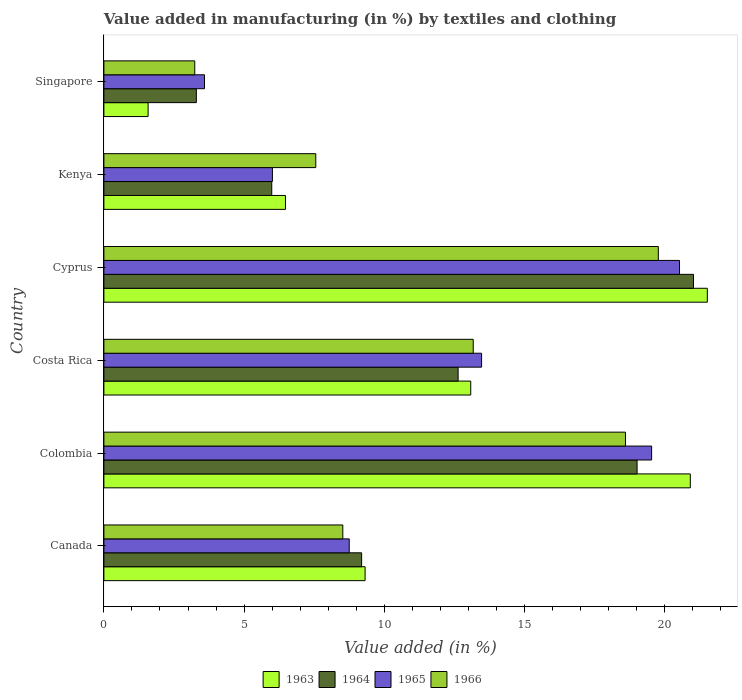Are the number of bars on each tick of the Y-axis equal?
Provide a short and direct response. Yes. How many bars are there on the 1st tick from the top?
Give a very brief answer. 4. How many bars are there on the 4th tick from the bottom?
Your answer should be compact. 4. What is the label of the 3rd group of bars from the top?
Your answer should be very brief. Cyprus. What is the percentage of value added in manufacturing by textiles and clothing in 1966 in Colombia?
Your response must be concise. 18.6. Across all countries, what is the maximum percentage of value added in manufacturing by textiles and clothing in 1966?
Your answer should be compact. 19.78. Across all countries, what is the minimum percentage of value added in manufacturing by textiles and clothing in 1966?
Give a very brief answer. 3.24. In which country was the percentage of value added in manufacturing by textiles and clothing in 1966 maximum?
Give a very brief answer. Cyprus. In which country was the percentage of value added in manufacturing by textiles and clothing in 1966 minimum?
Ensure brevity in your answer.  Singapore. What is the total percentage of value added in manufacturing by textiles and clothing in 1963 in the graph?
Offer a terse response. 72.9. What is the difference between the percentage of value added in manufacturing by textiles and clothing in 1964 in Costa Rica and that in Cyprus?
Keep it short and to the point. -8.4. What is the difference between the percentage of value added in manufacturing by textiles and clothing in 1963 in Costa Rica and the percentage of value added in manufacturing by textiles and clothing in 1964 in Singapore?
Your answer should be compact. 9.79. What is the average percentage of value added in manufacturing by textiles and clothing in 1966 per country?
Make the answer very short. 11.81. What is the difference between the percentage of value added in manufacturing by textiles and clothing in 1966 and percentage of value added in manufacturing by textiles and clothing in 1965 in Cyprus?
Your answer should be very brief. -0.76. In how many countries, is the percentage of value added in manufacturing by textiles and clothing in 1965 greater than 1 %?
Keep it short and to the point. 6. What is the ratio of the percentage of value added in manufacturing by textiles and clothing in 1966 in Canada to that in Singapore?
Offer a very short reply. 2.63. Is the percentage of value added in manufacturing by textiles and clothing in 1964 in Kenya less than that in Singapore?
Offer a very short reply. No. Is the difference between the percentage of value added in manufacturing by textiles and clothing in 1966 in Costa Rica and Cyprus greater than the difference between the percentage of value added in manufacturing by textiles and clothing in 1965 in Costa Rica and Cyprus?
Give a very brief answer. Yes. What is the difference between the highest and the second highest percentage of value added in manufacturing by textiles and clothing in 1966?
Give a very brief answer. 1.17. What is the difference between the highest and the lowest percentage of value added in manufacturing by textiles and clothing in 1963?
Your answer should be compact. 19.95. In how many countries, is the percentage of value added in manufacturing by textiles and clothing in 1964 greater than the average percentage of value added in manufacturing by textiles and clothing in 1964 taken over all countries?
Offer a terse response. 3. What does the 3rd bar from the top in Costa Rica represents?
Offer a terse response. 1964. What does the 3rd bar from the bottom in Kenya represents?
Your response must be concise. 1965. How many bars are there?
Your answer should be very brief. 24. How many countries are there in the graph?
Give a very brief answer. 6. What is the difference between two consecutive major ticks on the X-axis?
Your answer should be very brief. 5. Does the graph contain grids?
Provide a succinct answer. No. Where does the legend appear in the graph?
Your response must be concise. Bottom center. How many legend labels are there?
Give a very brief answer. 4. How are the legend labels stacked?
Your answer should be compact. Horizontal. What is the title of the graph?
Keep it short and to the point. Value added in manufacturing (in %) by textiles and clothing. Does "1987" appear as one of the legend labels in the graph?
Your answer should be compact. No. What is the label or title of the X-axis?
Make the answer very short. Value added (in %). What is the Value added (in %) in 1963 in Canada?
Ensure brevity in your answer.  9.32. What is the Value added (in %) of 1964 in Canada?
Give a very brief answer. 9.19. What is the Value added (in %) in 1965 in Canada?
Offer a very short reply. 8.75. What is the Value added (in %) in 1966 in Canada?
Offer a terse response. 8.52. What is the Value added (in %) of 1963 in Colombia?
Provide a succinct answer. 20.92. What is the Value added (in %) of 1964 in Colombia?
Keep it short and to the point. 19.02. What is the Value added (in %) of 1965 in Colombia?
Keep it short and to the point. 19.54. What is the Value added (in %) in 1966 in Colombia?
Make the answer very short. 18.6. What is the Value added (in %) in 1963 in Costa Rica?
Offer a very short reply. 13.08. What is the Value added (in %) in 1964 in Costa Rica?
Provide a short and direct response. 12.63. What is the Value added (in %) in 1965 in Costa Rica?
Provide a succinct answer. 13.47. What is the Value added (in %) in 1966 in Costa Rica?
Ensure brevity in your answer.  13.17. What is the Value added (in %) of 1963 in Cyprus?
Provide a short and direct response. 21.52. What is the Value added (in %) in 1964 in Cyprus?
Keep it short and to the point. 21.03. What is the Value added (in %) of 1965 in Cyprus?
Provide a succinct answer. 20.53. What is the Value added (in %) in 1966 in Cyprus?
Your answer should be compact. 19.78. What is the Value added (in %) in 1963 in Kenya?
Offer a very short reply. 6.48. What is the Value added (in %) of 1964 in Kenya?
Your answer should be very brief. 5.99. What is the Value added (in %) of 1965 in Kenya?
Ensure brevity in your answer.  6.01. What is the Value added (in %) of 1966 in Kenya?
Provide a succinct answer. 7.56. What is the Value added (in %) in 1963 in Singapore?
Your response must be concise. 1.58. What is the Value added (in %) of 1964 in Singapore?
Provide a succinct answer. 3.3. What is the Value added (in %) of 1965 in Singapore?
Provide a short and direct response. 3.59. What is the Value added (in %) of 1966 in Singapore?
Your answer should be compact. 3.24. Across all countries, what is the maximum Value added (in %) of 1963?
Provide a short and direct response. 21.52. Across all countries, what is the maximum Value added (in %) of 1964?
Your response must be concise. 21.03. Across all countries, what is the maximum Value added (in %) in 1965?
Ensure brevity in your answer.  20.53. Across all countries, what is the maximum Value added (in %) of 1966?
Ensure brevity in your answer.  19.78. Across all countries, what is the minimum Value added (in %) of 1963?
Your answer should be compact. 1.58. Across all countries, what is the minimum Value added (in %) of 1964?
Give a very brief answer. 3.3. Across all countries, what is the minimum Value added (in %) in 1965?
Offer a terse response. 3.59. Across all countries, what is the minimum Value added (in %) of 1966?
Offer a very short reply. 3.24. What is the total Value added (in %) in 1963 in the graph?
Your answer should be compact. 72.9. What is the total Value added (in %) in 1964 in the graph?
Your response must be concise. 71.16. What is the total Value added (in %) of 1965 in the graph?
Make the answer very short. 71.89. What is the total Value added (in %) of 1966 in the graph?
Offer a very short reply. 70.87. What is the difference between the Value added (in %) of 1963 in Canada and that in Colombia?
Provide a short and direct response. -11.6. What is the difference between the Value added (in %) in 1964 in Canada and that in Colombia?
Give a very brief answer. -9.82. What is the difference between the Value added (in %) in 1965 in Canada and that in Colombia?
Provide a short and direct response. -10.79. What is the difference between the Value added (in %) in 1966 in Canada and that in Colombia?
Your answer should be compact. -10.08. What is the difference between the Value added (in %) in 1963 in Canada and that in Costa Rica?
Provide a short and direct response. -3.77. What is the difference between the Value added (in %) in 1964 in Canada and that in Costa Rica?
Provide a succinct answer. -3.44. What is the difference between the Value added (in %) in 1965 in Canada and that in Costa Rica?
Give a very brief answer. -4.72. What is the difference between the Value added (in %) of 1966 in Canada and that in Costa Rica?
Your response must be concise. -4.65. What is the difference between the Value added (in %) of 1963 in Canada and that in Cyprus?
Ensure brevity in your answer.  -12.21. What is the difference between the Value added (in %) of 1964 in Canada and that in Cyprus?
Offer a very short reply. -11.84. What is the difference between the Value added (in %) in 1965 in Canada and that in Cyprus?
Your answer should be compact. -11.78. What is the difference between the Value added (in %) in 1966 in Canada and that in Cyprus?
Your response must be concise. -11.25. What is the difference between the Value added (in %) of 1963 in Canada and that in Kenya?
Your answer should be very brief. 2.84. What is the difference between the Value added (in %) in 1964 in Canada and that in Kenya?
Offer a very short reply. 3.21. What is the difference between the Value added (in %) of 1965 in Canada and that in Kenya?
Give a very brief answer. 2.74. What is the difference between the Value added (in %) in 1966 in Canada and that in Kenya?
Offer a very short reply. 0.96. What is the difference between the Value added (in %) in 1963 in Canada and that in Singapore?
Provide a succinct answer. 7.74. What is the difference between the Value added (in %) in 1964 in Canada and that in Singapore?
Provide a short and direct response. 5.9. What is the difference between the Value added (in %) of 1965 in Canada and that in Singapore?
Provide a succinct answer. 5.16. What is the difference between the Value added (in %) in 1966 in Canada and that in Singapore?
Your response must be concise. 5.28. What is the difference between the Value added (in %) in 1963 in Colombia and that in Costa Rica?
Ensure brevity in your answer.  7.83. What is the difference between the Value added (in %) in 1964 in Colombia and that in Costa Rica?
Provide a succinct answer. 6.38. What is the difference between the Value added (in %) of 1965 in Colombia and that in Costa Rica?
Provide a succinct answer. 6.06. What is the difference between the Value added (in %) of 1966 in Colombia and that in Costa Rica?
Make the answer very short. 5.43. What is the difference between the Value added (in %) in 1963 in Colombia and that in Cyprus?
Provide a succinct answer. -0.61. What is the difference between the Value added (in %) of 1964 in Colombia and that in Cyprus?
Make the answer very short. -2.01. What is the difference between the Value added (in %) of 1965 in Colombia and that in Cyprus?
Ensure brevity in your answer.  -0.99. What is the difference between the Value added (in %) in 1966 in Colombia and that in Cyprus?
Keep it short and to the point. -1.17. What is the difference between the Value added (in %) of 1963 in Colombia and that in Kenya?
Keep it short and to the point. 14.44. What is the difference between the Value added (in %) in 1964 in Colombia and that in Kenya?
Give a very brief answer. 13.03. What is the difference between the Value added (in %) of 1965 in Colombia and that in Kenya?
Your answer should be very brief. 13.53. What is the difference between the Value added (in %) in 1966 in Colombia and that in Kenya?
Your response must be concise. 11.05. What is the difference between the Value added (in %) of 1963 in Colombia and that in Singapore?
Offer a very short reply. 19.34. What is the difference between the Value added (in %) of 1964 in Colombia and that in Singapore?
Provide a succinct answer. 15.72. What is the difference between the Value added (in %) in 1965 in Colombia and that in Singapore?
Provide a short and direct response. 15.95. What is the difference between the Value added (in %) of 1966 in Colombia and that in Singapore?
Offer a very short reply. 15.36. What is the difference between the Value added (in %) in 1963 in Costa Rica and that in Cyprus?
Make the answer very short. -8.44. What is the difference between the Value added (in %) of 1964 in Costa Rica and that in Cyprus?
Make the answer very short. -8.4. What is the difference between the Value added (in %) of 1965 in Costa Rica and that in Cyprus?
Keep it short and to the point. -7.06. What is the difference between the Value added (in %) of 1966 in Costa Rica and that in Cyprus?
Make the answer very short. -6.6. What is the difference between the Value added (in %) in 1963 in Costa Rica and that in Kenya?
Make the answer very short. 6.61. What is the difference between the Value added (in %) of 1964 in Costa Rica and that in Kenya?
Provide a succinct answer. 6.65. What is the difference between the Value added (in %) of 1965 in Costa Rica and that in Kenya?
Your answer should be compact. 7.46. What is the difference between the Value added (in %) in 1966 in Costa Rica and that in Kenya?
Keep it short and to the point. 5.62. What is the difference between the Value added (in %) in 1963 in Costa Rica and that in Singapore?
Offer a very short reply. 11.51. What is the difference between the Value added (in %) in 1964 in Costa Rica and that in Singapore?
Give a very brief answer. 9.34. What is the difference between the Value added (in %) in 1965 in Costa Rica and that in Singapore?
Your answer should be compact. 9.88. What is the difference between the Value added (in %) in 1966 in Costa Rica and that in Singapore?
Offer a terse response. 9.93. What is the difference between the Value added (in %) in 1963 in Cyprus and that in Kenya?
Offer a terse response. 15.05. What is the difference between the Value added (in %) in 1964 in Cyprus and that in Kenya?
Your answer should be compact. 15.04. What is the difference between the Value added (in %) of 1965 in Cyprus and that in Kenya?
Your answer should be compact. 14.52. What is the difference between the Value added (in %) in 1966 in Cyprus and that in Kenya?
Offer a very short reply. 12.22. What is the difference between the Value added (in %) of 1963 in Cyprus and that in Singapore?
Keep it short and to the point. 19.95. What is the difference between the Value added (in %) of 1964 in Cyprus and that in Singapore?
Your answer should be very brief. 17.73. What is the difference between the Value added (in %) of 1965 in Cyprus and that in Singapore?
Keep it short and to the point. 16.94. What is the difference between the Value added (in %) in 1966 in Cyprus and that in Singapore?
Your response must be concise. 16.53. What is the difference between the Value added (in %) of 1963 in Kenya and that in Singapore?
Keep it short and to the point. 4.9. What is the difference between the Value added (in %) in 1964 in Kenya and that in Singapore?
Your answer should be compact. 2.69. What is the difference between the Value added (in %) in 1965 in Kenya and that in Singapore?
Offer a terse response. 2.42. What is the difference between the Value added (in %) in 1966 in Kenya and that in Singapore?
Your answer should be very brief. 4.32. What is the difference between the Value added (in %) in 1963 in Canada and the Value added (in %) in 1964 in Colombia?
Provide a succinct answer. -9.7. What is the difference between the Value added (in %) of 1963 in Canada and the Value added (in %) of 1965 in Colombia?
Keep it short and to the point. -10.22. What is the difference between the Value added (in %) of 1963 in Canada and the Value added (in %) of 1966 in Colombia?
Your answer should be very brief. -9.29. What is the difference between the Value added (in %) of 1964 in Canada and the Value added (in %) of 1965 in Colombia?
Your answer should be compact. -10.34. What is the difference between the Value added (in %) of 1964 in Canada and the Value added (in %) of 1966 in Colombia?
Your answer should be compact. -9.41. What is the difference between the Value added (in %) in 1965 in Canada and the Value added (in %) in 1966 in Colombia?
Your answer should be very brief. -9.85. What is the difference between the Value added (in %) of 1963 in Canada and the Value added (in %) of 1964 in Costa Rica?
Ensure brevity in your answer.  -3.32. What is the difference between the Value added (in %) of 1963 in Canada and the Value added (in %) of 1965 in Costa Rica?
Your response must be concise. -4.16. What is the difference between the Value added (in %) in 1963 in Canada and the Value added (in %) in 1966 in Costa Rica?
Provide a short and direct response. -3.86. What is the difference between the Value added (in %) of 1964 in Canada and the Value added (in %) of 1965 in Costa Rica?
Provide a succinct answer. -4.28. What is the difference between the Value added (in %) of 1964 in Canada and the Value added (in %) of 1966 in Costa Rica?
Provide a succinct answer. -3.98. What is the difference between the Value added (in %) of 1965 in Canada and the Value added (in %) of 1966 in Costa Rica?
Make the answer very short. -4.42. What is the difference between the Value added (in %) in 1963 in Canada and the Value added (in %) in 1964 in Cyprus?
Offer a very short reply. -11.71. What is the difference between the Value added (in %) in 1963 in Canada and the Value added (in %) in 1965 in Cyprus?
Your response must be concise. -11.21. What is the difference between the Value added (in %) in 1963 in Canada and the Value added (in %) in 1966 in Cyprus?
Your answer should be compact. -10.46. What is the difference between the Value added (in %) of 1964 in Canada and the Value added (in %) of 1965 in Cyprus?
Provide a short and direct response. -11.34. What is the difference between the Value added (in %) of 1964 in Canada and the Value added (in %) of 1966 in Cyprus?
Make the answer very short. -10.58. What is the difference between the Value added (in %) in 1965 in Canada and the Value added (in %) in 1966 in Cyprus?
Offer a terse response. -11.02. What is the difference between the Value added (in %) in 1963 in Canada and the Value added (in %) in 1964 in Kenya?
Your answer should be compact. 3.33. What is the difference between the Value added (in %) of 1963 in Canada and the Value added (in %) of 1965 in Kenya?
Offer a terse response. 3.31. What is the difference between the Value added (in %) in 1963 in Canada and the Value added (in %) in 1966 in Kenya?
Your answer should be very brief. 1.76. What is the difference between the Value added (in %) of 1964 in Canada and the Value added (in %) of 1965 in Kenya?
Make the answer very short. 3.18. What is the difference between the Value added (in %) of 1964 in Canada and the Value added (in %) of 1966 in Kenya?
Offer a terse response. 1.64. What is the difference between the Value added (in %) in 1965 in Canada and the Value added (in %) in 1966 in Kenya?
Ensure brevity in your answer.  1.19. What is the difference between the Value added (in %) of 1963 in Canada and the Value added (in %) of 1964 in Singapore?
Offer a very short reply. 6.02. What is the difference between the Value added (in %) in 1963 in Canada and the Value added (in %) in 1965 in Singapore?
Offer a terse response. 5.73. What is the difference between the Value added (in %) of 1963 in Canada and the Value added (in %) of 1966 in Singapore?
Keep it short and to the point. 6.08. What is the difference between the Value added (in %) of 1964 in Canada and the Value added (in %) of 1965 in Singapore?
Your answer should be very brief. 5.6. What is the difference between the Value added (in %) of 1964 in Canada and the Value added (in %) of 1966 in Singapore?
Give a very brief answer. 5.95. What is the difference between the Value added (in %) in 1965 in Canada and the Value added (in %) in 1966 in Singapore?
Give a very brief answer. 5.51. What is the difference between the Value added (in %) of 1963 in Colombia and the Value added (in %) of 1964 in Costa Rica?
Provide a succinct answer. 8.28. What is the difference between the Value added (in %) in 1963 in Colombia and the Value added (in %) in 1965 in Costa Rica?
Provide a short and direct response. 7.44. What is the difference between the Value added (in %) in 1963 in Colombia and the Value added (in %) in 1966 in Costa Rica?
Your response must be concise. 7.74. What is the difference between the Value added (in %) of 1964 in Colombia and the Value added (in %) of 1965 in Costa Rica?
Your answer should be compact. 5.55. What is the difference between the Value added (in %) in 1964 in Colombia and the Value added (in %) in 1966 in Costa Rica?
Your answer should be very brief. 5.84. What is the difference between the Value added (in %) of 1965 in Colombia and the Value added (in %) of 1966 in Costa Rica?
Ensure brevity in your answer.  6.36. What is the difference between the Value added (in %) in 1963 in Colombia and the Value added (in %) in 1964 in Cyprus?
Keep it short and to the point. -0.11. What is the difference between the Value added (in %) in 1963 in Colombia and the Value added (in %) in 1965 in Cyprus?
Provide a succinct answer. 0.39. What is the difference between the Value added (in %) of 1963 in Colombia and the Value added (in %) of 1966 in Cyprus?
Provide a succinct answer. 1.14. What is the difference between the Value added (in %) in 1964 in Colombia and the Value added (in %) in 1965 in Cyprus?
Your response must be concise. -1.51. What is the difference between the Value added (in %) of 1964 in Colombia and the Value added (in %) of 1966 in Cyprus?
Provide a short and direct response. -0.76. What is the difference between the Value added (in %) in 1965 in Colombia and the Value added (in %) in 1966 in Cyprus?
Offer a terse response. -0.24. What is the difference between the Value added (in %) of 1963 in Colombia and the Value added (in %) of 1964 in Kenya?
Your answer should be compact. 14.93. What is the difference between the Value added (in %) in 1963 in Colombia and the Value added (in %) in 1965 in Kenya?
Your response must be concise. 14.91. What is the difference between the Value added (in %) in 1963 in Colombia and the Value added (in %) in 1966 in Kenya?
Ensure brevity in your answer.  13.36. What is the difference between the Value added (in %) in 1964 in Colombia and the Value added (in %) in 1965 in Kenya?
Provide a succinct answer. 13.01. What is the difference between the Value added (in %) of 1964 in Colombia and the Value added (in %) of 1966 in Kenya?
Your response must be concise. 11.46. What is the difference between the Value added (in %) in 1965 in Colombia and the Value added (in %) in 1966 in Kenya?
Ensure brevity in your answer.  11.98. What is the difference between the Value added (in %) in 1963 in Colombia and the Value added (in %) in 1964 in Singapore?
Make the answer very short. 17.62. What is the difference between the Value added (in %) of 1963 in Colombia and the Value added (in %) of 1965 in Singapore?
Provide a short and direct response. 17.33. What is the difference between the Value added (in %) in 1963 in Colombia and the Value added (in %) in 1966 in Singapore?
Your answer should be very brief. 17.68. What is the difference between the Value added (in %) of 1964 in Colombia and the Value added (in %) of 1965 in Singapore?
Your answer should be compact. 15.43. What is the difference between the Value added (in %) of 1964 in Colombia and the Value added (in %) of 1966 in Singapore?
Ensure brevity in your answer.  15.78. What is the difference between the Value added (in %) of 1965 in Colombia and the Value added (in %) of 1966 in Singapore?
Offer a very short reply. 16.3. What is the difference between the Value added (in %) of 1963 in Costa Rica and the Value added (in %) of 1964 in Cyprus?
Make the answer very short. -7.95. What is the difference between the Value added (in %) in 1963 in Costa Rica and the Value added (in %) in 1965 in Cyprus?
Your answer should be very brief. -7.45. What is the difference between the Value added (in %) of 1963 in Costa Rica and the Value added (in %) of 1966 in Cyprus?
Provide a short and direct response. -6.69. What is the difference between the Value added (in %) in 1964 in Costa Rica and the Value added (in %) in 1965 in Cyprus?
Ensure brevity in your answer.  -7.9. What is the difference between the Value added (in %) in 1964 in Costa Rica and the Value added (in %) in 1966 in Cyprus?
Your answer should be very brief. -7.14. What is the difference between the Value added (in %) of 1965 in Costa Rica and the Value added (in %) of 1966 in Cyprus?
Offer a terse response. -6.3. What is the difference between the Value added (in %) in 1963 in Costa Rica and the Value added (in %) in 1964 in Kenya?
Ensure brevity in your answer.  7.1. What is the difference between the Value added (in %) in 1963 in Costa Rica and the Value added (in %) in 1965 in Kenya?
Your answer should be compact. 7.07. What is the difference between the Value added (in %) in 1963 in Costa Rica and the Value added (in %) in 1966 in Kenya?
Provide a short and direct response. 5.53. What is the difference between the Value added (in %) of 1964 in Costa Rica and the Value added (in %) of 1965 in Kenya?
Make the answer very short. 6.62. What is the difference between the Value added (in %) in 1964 in Costa Rica and the Value added (in %) in 1966 in Kenya?
Your answer should be compact. 5.08. What is the difference between the Value added (in %) in 1965 in Costa Rica and the Value added (in %) in 1966 in Kenya?
Provide a succinct answer. 5.91. What is the difference between the Value added (in %) of 1963 in Costa Rica and the Value added (in %) of 1964 in Singapore?
Provide a succinct answer. 9.79. What is the difference between the Value added (in %) of 1963 in Costa Rica and the Value added (in %) of 1965 in Singapore?
Offer a terse response. 9.5. What is the difference between the Value added (in %) of 1963 in Costa Rica and the Value added (in %) of 1966 in Singapore?
Ensure brevity in your answer.  9.84. What is the difference between the Value added (in %) of 1964 in Costa Rica and the Value added (in %) of 1965 in Singapore?
Provide a short and direct response. 9.04. What is the difference between the Value added (in %) of 1964 in Costa Rica and the Value added (in %) of 1966 in Singapore?
Offer a terse response. 9.39. What is the difference between the Value added (in %) in 1965 in Costa Rica and the Value added (in %) in 1966 in Singapore?
Provide a short and direct response. 10.23. What is the difference between the Value added (in %) in 1963 in Cyprus and the Value added (in %) in 1964 in Kenya?
Provide a succinct answer. 15.54. What is the difference between the Value added (in %) in 1963 in Cyprus and the Value added (in %) in 1965 in Kenya?
Offer a terse response. 15.51. What is the difference between the Value added (in %) of 1963 in Cyprus and the Value added (in %) of 1966 in Kenya?
Provide a short and direct response. 13.97. What is the difference between the Value added (in %) of 1964 in Cyprus and the Value added (in %) of 1965 in Kenya?
Keep it short and to the point. 15.02. What is the difference between the Value added (in %) in 1964 in Cyprus and the Value added (in %) in 1966 in Kenya?
Your answer should be compact. 13.47. What is the difference between the Value added (in %) of 1965 in Cyprus and the Value added (in %) of 1966 in Kenya?
Make the answer very short. 12.97. What is the difference between the Value added (in %) in 1963 in Cyprus and the Value added (in %) in 1964 in Singapore?
Your answer should be very brief. 18.23. What is the difference between the Value added (in %) of 1963 in Cyprus and the Value added (in %) of 1965 in Singapore?
Offer a terse response. 17.93. What is the difference between the Value added (in %) of 1963 in Cyprus and the Value added (in %) of 1966 in Singapore?
Keep it short and to the point. 18.28. What is the difference between the Value added (in %) in 1964 in Cyprus and the Value added (in %) in 1965 in Singapore?
Ensure brevity in your answer.  17.44. What is the difference between the Value added (in %) in 1964 in Cyprus and the Value added (in %) in 1966 in Singapore?
Give a very brief answer. 17.79. What is the difference between the Value added (in %) in 1965 in Cyprus and the Value added (in %) in 1966 in Singapore?
Your answer should be compact. 17.29. What is the difference between the Value added (in %) of 1963 in Kenya and the Value added (in %) of 1964 in Singapore?
Offer a very short reply. 3.18. What is the difference between the Value added (in %) of 1963 in Kenya and the Value added (in %) of 1965 in Singapore?
Offer a terse response. 2.89. What is the difference between the Value added (in %) in 1963 in Kenya and the Value added (in %) in 1966 in Singapore?
Ensure brevity in your answer.  3.24. What is the difference between the Value added (in %) in 1964 in Kenya and the Value added (in %) in 1965 in Singapore?
Offer a terse response. 2.4. What is the difference between the Value added (in %) of 1964 in Kenya and the Value added (in %) of 1966 in Singapore?
Your answer should be compact. 2.75. What is the difference between the Value added (in %) in 1965 in Kenya and the Value added (in %) in 1966 in Singapore?
Ensure brevity in your answer.  2.77. What is the average Value added (in %) in 1963 per country?
Ensure brevity in your answer.  12.15. What is the average Value added (in %) of 1964 per country?
Offer a terse response. 11.86. What is the average Value added (in %) in 1965 per country?
Provide a succinct answer. 11.98. What is the average Value added (in %) in 1966 per country?
Your response must be concise. 11.81. What is the difference between the Value added (in %) in 1963 and Value added (in %) in 1964 in Canada?
Give a very brief answer. 0.12. What is the difference between the Value added (in %) of 1963 and Value added (in %) of 1965 in Canada?
Provide a short and direct response. 0.57. What is the difference between the Value added (in %) in 1963 and Value added (in %) in 1966 in Canada?
Your answer should be very brief. 0.8. What is the difference between the Value added (in %) of 1964 and Value added (in %) of 1965 in Canada?
Your answer should be compact. 0.44. What is the difference between the Value added (in %) in 1964 and Value added (in %) in 1966 in Canada?
Your answer should be compact. 0.67. What is the difference between the Value added (in %) of 1965 and Value added (in %) of 1966 in Canada?
Your response must be concise. 0.23. What is the difference between the Value added (in %) in 1963 and Value added (in %) in 1964 in Colombia?
Your answer should be very brief. 1.9. What is the difference between the Value added (in %) of 1963 and Value added (in %) of 1965 in Colombia?
Your answer should be very brief. 1.38. What is the difference between the Value added (in %) in 1963 and Value added (in %) in 1966 in Colombia?
Make the answer very short. 2.31. What is the difference between the Value added (in %) of 1964 and Value added (in %) of 1965 in Colombia?
Offer a very short reply. -0.52. What is the difference between the Value added (in %) of 1964 and Value added (in %) of 1966 in Colombia?
Your answer should be very brief. 0.41. What is the difference between the Value added (in %) of 1965 and Value added (in %) of 1966 in Colombia?
Offer a very short reply. 0.93. What is the difference between the Value added (in %) in 1963 and Value added (in %) in 1964 in Costa Rica?
Offer a very short reply. 0.45. What is the difference between the Value added (in %) in 1963 and Value added (in %) in 1965 in Costa Rica?
Provide a succinct answer. -0.39. What is the difference between the Value added (in %) of 1963 and Value added (in %) of 1966 in Costa Rica?
Your answer should be very brief. -0.09. What is the difference between the Value added (in %) in 1964 and Value added (in %) in 1965 in Costa Rica?
Provide a short and direct response. -0.84. What is the difference between the Value added (in %) of 1964 and Value added (in %) of 1966 in Costa Rica?
Your answer should be compact. -0.54. What is the difference between the Value added (in %) in 1965 and Value added (in %) in 1966 in Costa Rica?
Offer a terse response. 0.3. What is the difference between the Value added (in %) of 1963 and Value added (in %) of 1964 in Cyprus?
Provide a short and direct response. 0.49. What is the difference between the Value added (in %) in 1963 and Value added (in %) in 1966 in Cyprus?
Offer a very short reply. 1.75. What is the difference between the Value added (in %) of 1964 and Value added (in %) of 1965 in Cyprus?
Ensure brevity in your answer.  0.5. What is the difference between the Value added (in %) of 1964 and Value added (in %) of 1966 in Cyprus?
Keep it short and to the point. 1.25. What is the difference between the Value added (in %) of 1965 and Value added (in %) of 1966 in Cyprus?
Your answer should be compact. 0.76. What is the difference between the Value added (in %) in 1963 and Value added (in %) in 1964 in Kenya?
Keep it short and to the point. 0.49. What is the difference between the Value added (in %) in 1963 and Value added (in %) in 1965 in Kenya?
Provide a short and direct response. 0.47. What is the difference between the Value added (in %) of 1963 and Value added (in %) of 1966 in Kenya?
Give a very brief answer. -1.08. What is the difference between the Value added (in %) in 1964 and Value added (in %) in 1965 in Kenya?
Make the answer very short. -0.02. What is the difference between the Value added (in %) of 1964 and Value added (in %) of 1966 in Kenya?
Keep it short and to the point. -1.57. What is the difference between the Value added (in %) of 1965 and Value added (in %) of 1966 in Kenya?
Give a very brief answer. -1.55. What is the difference between the Value added (in %) of 1963 and Value added (in %) of 1964 in Singapore?
Provide a succinct answer. -1.72. What is the difference between the Value added (in %) in 1963 and Value added (in %) in 1965 in Singapore?
Keep it short and to the point. -2.01. What is the difference between the Value added (in %) in 1963 and Value added (in %) in 1966 in Singapore?
Your response must be concise. -1.66. What is the difference between the Value added (in %) in 1964 and Value added (in %) in 1965 in Singapore?
Your answer should be very brief. -0.29. What is the difference between the Value added (in %) in 1964 and Value added (in %) in 1966 in Singapore?
Provide a short and direct response. 0.06. What is the difference between the Value added (in %) of 1965 and Value added (in %) of 1966 in Singapore?
Your answer should be very brief. 0.35. What is the ratio of the Value added (in %) of 1963 in Canada to that in Colombia?
Provide a succinct answer. 0.45. What is the ratio of the Value added (in %) in 1964 in Canada to that in Colombia?
Your answer should be compact. 0.48. What is the ratio of the Value added (in %) in 1965 in Canada to that in Colombia?
Your response must be concise. 0.45. What is the ratio of the Value added (in %) in 1966 in Canada to that in Colombia?
Give a very brief answer. 0.46. What is the ratio of the Value added (in %) of 1963 in Canada to that in Costa Rica?
Make the answer very short. 0.71. What is the ratio of the Value added (in %) in 1964 in Canada to that in Costa Rica?
Provide a short and direct response. 0.73. What is the ratio of the Value added (in %) of 1965 in Canada to that in Costa Rica?
Offer a very short reply. 0.65. What is the ratio of the Value added (in %) in 1966 in Canada to that in Costa Rica?
Your response must be concise. 0.65. What is the ratio of the Value added (in %) in 1963 in Canada to that in Cyprus?
Ensure brevity in your answer.  0.43. What is the ratio of the Value added (in %) of 1964 in Canada to that in Cyprus?
Give a very brief answer. 0.44. What is the ratio of the Value added (in %) in 1965 in Canada to that in Cyprus?
Give a very brief answer. 0.43. What is the ratio of the Value added (in %) in 1966 in Canada to that in Cyprus?
Ensure brevity in your answer.  0.43. What is the ratio of the Value added (in %) of 1963 in Canada to that in Kenya?
Your response must be concise. 1.44. What is the ratio of the Value added (in %) of 1964 in Canada to that in Kenya?
Provide a short and direct response. 1.54. What is the ratio of the Value added (in %) in 1965 in Canada to that in Kenya?
Ensure brevity in your answer.  1.46. What is the ratio of the Value added (in %) in 1966 in Canada to that in Kenya?
Your response must be concise. 1.13. What is the ratio of the Value added (in %) of 1963 in Canada to that in Singapore?
Provide a short and direct response. 5.91. What is the ratio of the Value added (in %) in 1964 in Canada to that in Singapore?
Ensure brevity in your answer.  2.79. What is the ratio of the Value added (in %) in 1965 in Canada to that in Singapore?
Offer a very short reply. 2.44. What is the ratio of the Value added (in %) in 1966 in Canada to that in Singapore?
Make the answer very short. 2.63. What is the ratio of the Value added (in %) of 1963 in Colombia to that in Costa Rica?
Your response must be concise. 1.6. What is the ratio of the Value added (in %) in 1964 in Colombia to that in Costa Rica?
Make the answer very short. 1.51. What is the ratio of the Value added (in %) of 1965 in Colombia to that in Costa Rica?
Offer a very short reply. 1.45. What is the ratio of the Value added (in %) of 1966 in Colombia to that in Costa Rica?
Ensure brevity in your answer.  1.41. What is the ratio of the Value added (in %) in 1963 in Colombia to that in Cyprus?
Your response must be concise. 0.97. What is the ratio of the Value added (in %) of 1964 in Colombia to that in Cyprus?
Provide a succinct answer. 0.9. What is the ratio of the Value added (in %) in 1965 in Colombia to that in Cyprus?
Provide a succinct answer. 0.95. What is the ratio of the Value added (in %) in 1966 in Colombia to that in Cyprus?
Offer a terse response. 0.94. What is the ratio of the Value added (in %) of 1963 in Colombia to that in Kenya?
Offer a very short reply. 3.23. What is the ratio of the Value added (in %) of 1964 in Colombia to that in Kenya?
Provide a succinct answer. 3.18. What is the ratio of the Value added (in %) in 1966 in Colombia to that in Kenya?
Offer a very short reply. 2.46. What is the ratio of the Value added (in %) in 1963 in Colombia to that in Singapore?
Your answer should be compact. 13.26. What is the ratio of the Value added (in %) in 1964 in Colombia to that in Singapore?
Provide a succinct answer. 5.77. What is the ratio of the Value added (in %) of 1965 in Colombia to that in Singapore?
Provide a succinct answer. 5.44. What is the ratio of the Value added (in %) of 1966 in Colombia to that in Singapore?
Make the answer very short. 5.74. What is the ratio of the Value added (in %) of 1963 in Costa Rica to that in Cyprus?
Keep it short and to the point. 0.61. What is the ratio of the Value added (in %) of 1964 in Costa Rica to that in Cyprus?
Offer a very short reply. 0.6. What is the ratio of the Value added (in %) in 1965 in Costa Rica to that in Cyprus?
Give a very brief answer. 0.66. What is the ratio of the Value added (in %) in 1966 in Costa Rica to that in Cyprus?
Make the answer very short. 0.67. What is the ratio of the Value added (in %) in 1963 in Costa Rica to that in Kenya?
Provide a short and direct response. 2.02. What is the ratio of the Value added (in %) of 1964 in Costa Rica to that in Kenya?
Ensure brevity in your answer.  2.11. What is the ratio of the Value added (in %) of 1965 in Costa Rica to that in Kenya?
Your answer should be compact. 2.24. What is the ratio of the Value added (in %) in 1966 in Costa Rica to that in Kenya?
Provide a short and direct response. 1.74. What is the ratio of the Value added (in %) in 1963 in Costa Rica to that in Singapore?
Provide a short and direct response. 8.3. What is the ratio of the Value added (in %) of 1964 in Costa Rica to that in Singapore?
Ensure brevity in your answer.  3.83. What is the ratio of the Value added (in %) in 1965 in Costa Rica to that in Singapore?
Offer a very short reply. 3.75. What is the ratio of the Value added (in %) in 1966 in Costa Rica to that in Singapore?
Keep it short and to the point. 4.06. What is the ratio of the Value added (in %) in 1963 in Cyprus to that in Kenya?
Give a very brief answer. 3.32. What is the ratio of the Value added (in %) of 1964 in Cyprus to that in Kenya?
Your answer should be compact. 3.51. What is the ratio of the Value added (in %) of 1965 in Cyprus to that in Kenya?
Offer a terse response. 3.42. What is the ratio of the Value added (in %) of 1966 in Cyprus to that in Kenya?
Provide a short and direct response. 2.62. What is the ratio of the Value added (in %) of 1963 in Cyprus to that in Singapore?
Your answer should be compact. 13.65. What is the ratio of the Value added (in %) of 1964 in Cyprus to that in Singapore?
Provide a succinct answer. 6.38. What is the ratio of the Value added (in %) of 1965 in Cyprus to that in Singapore?
Provide a succinct answer. 5.72. What is the ratio of the Value added (in %) in 1966 in Cyprus to that in Singapore?
Your answer should be very brief. 6.1. What is the ratio of the Value added (in %) in 1963 in Kenya to that in Singapore?
Offer a very short reply. 4.11. What is the ratio of the Value added (in %) of 1964 in Kenya to that in Singapore?
Offer a very short reply. 1.82. What is the ratio of the Value added (in %) in 1965 in Kenya to that in Singapore?
Offer a terse response. 1.67. What is the ratio of the Value added (in %) in 1966 in Kenya to that in Singapore?
Provide a succinct answer. 2.33. What is the difference between the highest and the second highest Value added (in %) of 1963?
Keep it short and to the point. 0.61. What is the difference between the highest and the second highest Value added (in %) in 1964?
Keep it short and to the point. 2.01. What is the difference between the highest and the second highest Value added (in %) in 1965?
Offer a terse response. 0.99. What is the difference between the highest and the second highest Value added (in %) in 1966?
Ensure brevity in your answer.  1.17. What is the difference between the highest and the lowest Value added (in %) of 1963?
Ensure brevity in your answer.  19.95. What is the difference between the highest and the lowest Value added (in %) of 1964?
Keep it short and to the point. 17.73. What is the difference between the highest and the lowest Value added (in %) in 1965?
Offer a terse response. 16.94. What is the difference between the highest and the lowest Value added (in %) in 1966?
Offer a very short reply. 16.53. 